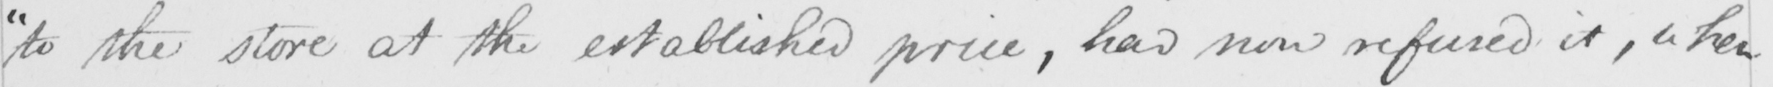Can you read and transcribe this handwriting? " to the store at the established price , had now refused it , when 